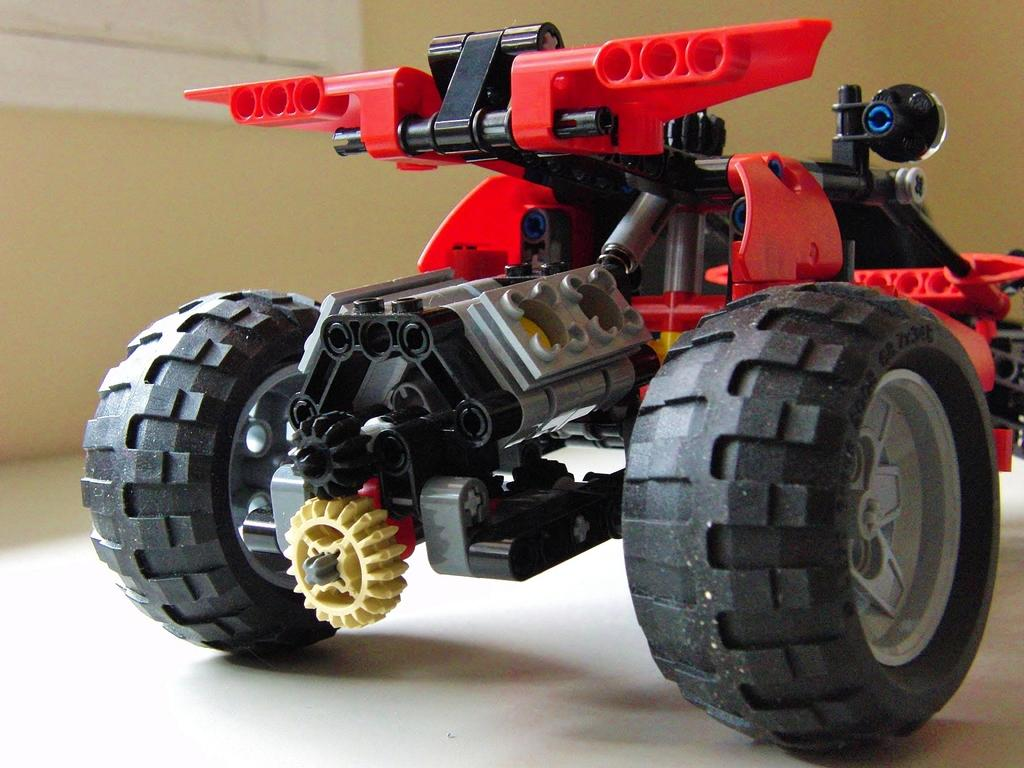What type of toy is visible in the image? There is a toy vehicle in the image. Where is the toy vehicle located? The toy vehicle is on the floor. What can be seen in the background of the image? There is a wall in the background of the image. Can you see a giraffe in the nest in the image? There is no giraffe or nest present in the image. 